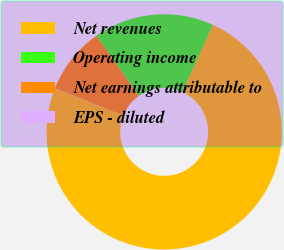Convert chart. <chart><loc_0><loc_0><loc_500><loc_500><pie_chart><fcel>Net revenues<fcel>Operating income<fcel>Net earnings attributable to<fcel>EPS - diluted<nl><fcel>74.26%<fcel>16.58%<fcel>9.16%<fcel>0.01%<nl></chart> 